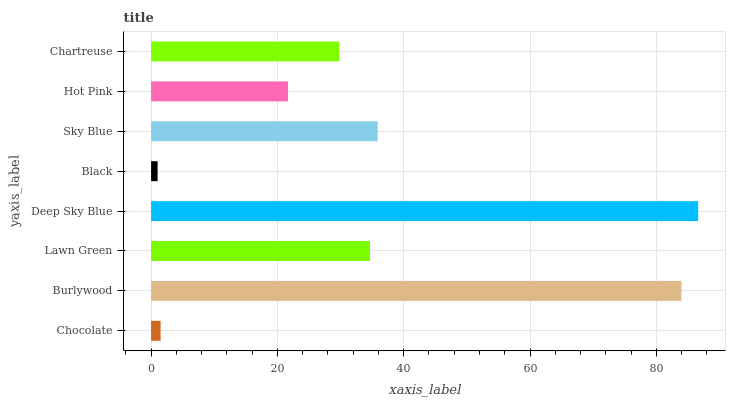Is Black the minimum?
Answer yes or no. Yes. Is Deep Sky Blue the maximum?
Answer yes or no. Yes. Is Burlywood the minimum?
Answer yes or no. No. Is Burlywood the maximum?
Answer yes or no. No. Is Burlywood greater than Chocolate?
Answer yes or no. Yes. Is Chocolate less than Burlywood?
Answer yes or no. Yes. Is Chocolate greater than Burlywood?
Answer yes or no. No. Is Burlywood less than Chocolate?
Answer yes or no. No. Is Lawn Green the high median?
Answer yes or no. Yes. Is Chartreuse the low median?
Answer yes or no. Yes. Is Chocolate the high median?
Answer yes or no. No. Is Black the low median?
Answer yes or no. No. 